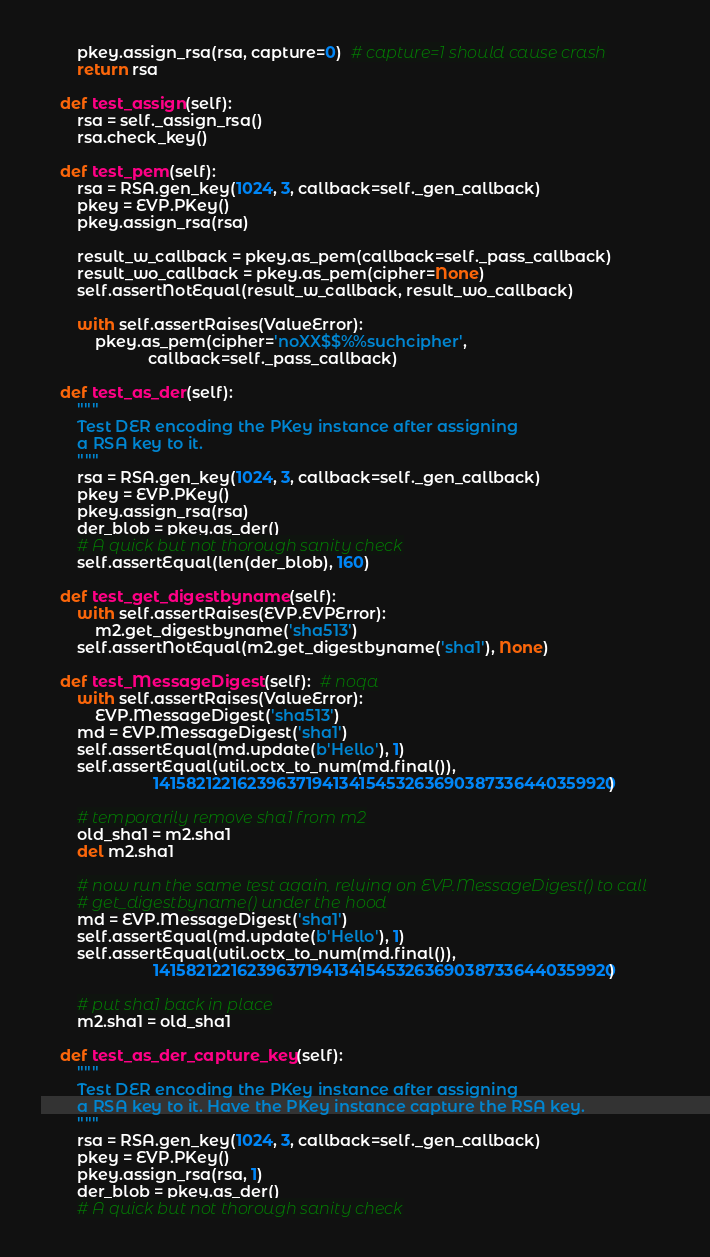<code> <loc_0><loc_0><loc_500><loc_500><_Python_>        pkey.assign_rsa(rsa, capture=0)  # capture=1 should cause crash
        return rsa

    def test_assign(self):
        rsa = self._assign_rsa()
        rsa.check_key()

    def test_pem(self):
        rsa = RSA.gen_key(1024, 3, callback=self._gen_callback)
        pkey = EVP.PKey()
        pkey.assign_rsa(rsa)

        result_w_callback = pkey.as_pem(callback=self._pass_callback)
        result_wo_callback = pkey.as_pem(cipher=None)
        self.assertNotEqual(result_w_callback, result_wo_callback)

        with self.assertRaises(ValueError):
            pkey.as_pem(cipher='noXX$$%%suchcipher',
                        callback=self._pass_callback)

    def test_as_der(self):
        """
        Test DER encoding the PKey instance after assigning
        a RSA key to it.
        """
        rsa = RSA.gen_key(1024, 3, callback=self._gen_callback)
        pkey = EVP.PKey()
        pkey.assign_rsa(rsa)
        der_blob = pkey.as_der()
        # A quick but not thorough sanity check
        self.assertEqual(len(der_blob), 160)

    def test_get_digestbyname(self):
        with self.assertRaises(EVP.EVPError):
            m2.get_digestbyname('sha513')
        self.assertNotEqual(m2.get_digestbyname('sha1'), None)

    def test_MessageDigest(self):  # noqa
        with self.assertRaises(ValueError):
            EVP.MessageDigest('sha513')
        md = EVP.MessageDigest('sha1')
        self.assertEqual(md.update(b'Hello'), 1)
        self.assertEqual(util.octx_to_num(md.final()),
                         1415821221623963719413415453263690387336440359920)

        # temporarily remove sha1 from m2
        old_sha1 = m2.sha1
        del m2.sha1

        # now run the same test again, relying on EVP.MessageDigest() to call
        # get_digestbyname() under the hood
        md = EVP.MessageDigest('sha1')
        self.assertEqual(md.update(b'Hello'), 1)
        self.assertEqual(util.octx_to_num(md.final()),
                         1415821221623963719413415453263690387336440359920)

        # put sha1 back in place
        m2.sha1 = old_sha1

    def test_as_der_capture_key(self):
        """
        Test DER encoding the PKey instance after assigning
        a RSA key to it. Have the PKey instance capture the RSA key.
        """
        rsa = RSA.gen_key(1024, 3, callback=self._gen_callback)
        pkey = EVP.PKey()
        pkey.assign_rsa(rsa, 1)
        der_blob = pkey.as_der()
        # A quick but not thorough sanity check</code> 